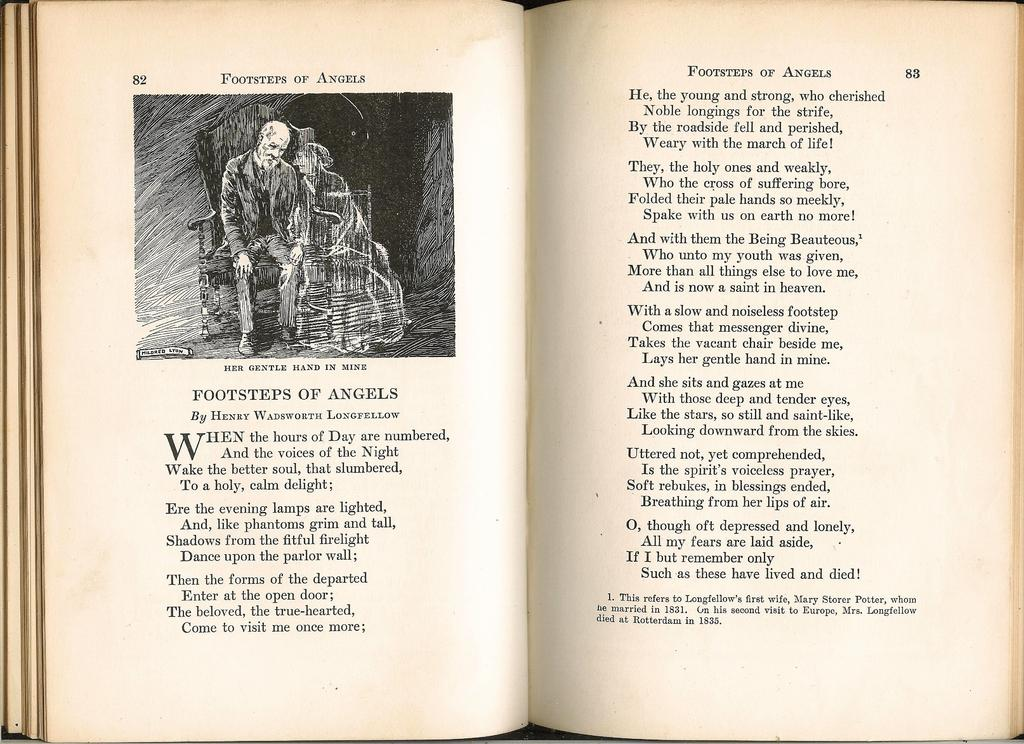<image>
Create a compact narrative representing the image presented. an old book open to page 82 and 83 titled footsteps of angels 